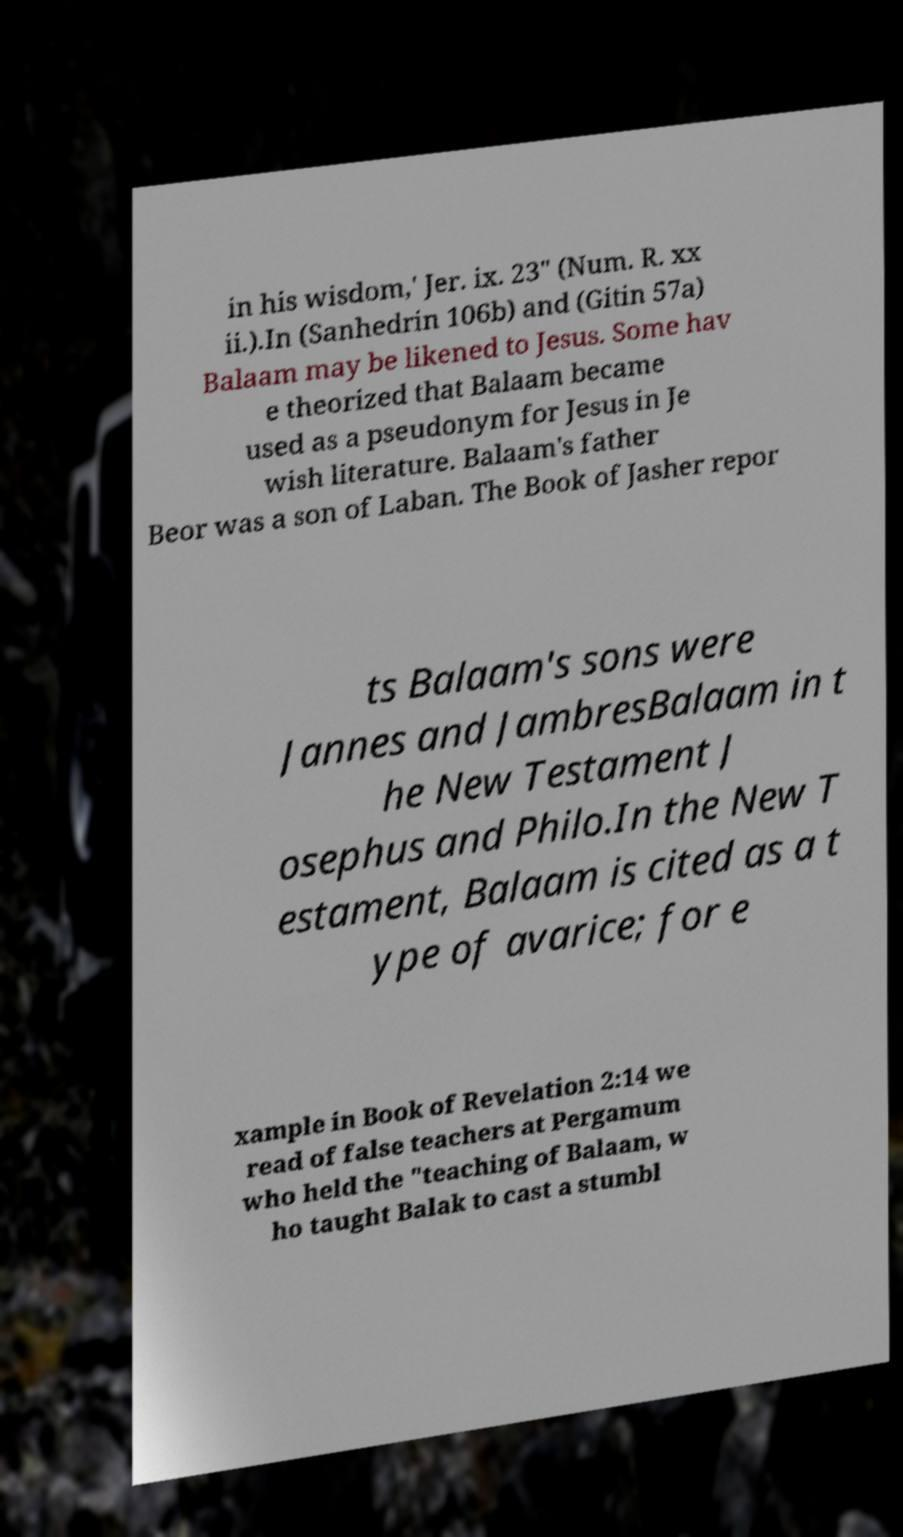Please identify and transcribe the text found in this image. in his wisdom,' Jer. ix. 23" (Num. R. xx ii.).In (Sanhedrin 106b) and (Gitin 57a) Balaam may be likened to Jesus. Some hav e theorized that Balaam became used as a pseudonym for Jesus in Je wish literature. Balaam's father Beor was a son of Laban. The Book of Jasher repor ts Balaam's sons were Jannes and JambresBalaam in t he New Testament J osephus and Philo.In the New T estament, Balaam is cited as a t ype of avarice; for e xample in Book of Revelation 2:14 we read of false teachers at Pergamum who held the "teaching of Balaam, w ho taught Balak to cast a stumbl 